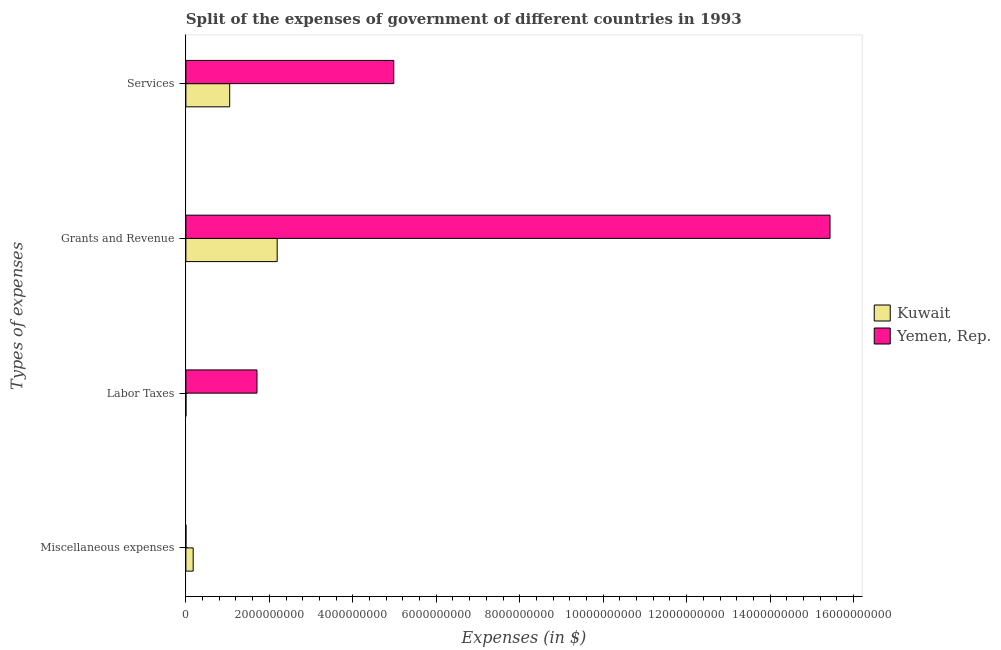Are the number of bars on each tick of the Y-axis equal?
Offer a very short reply. Yes. What is the label of the 2nd group of bars from the top?
Make the answer very short. Grants and Revenue. What is the amount spent on miscellaneous expenses in Yemen, Rep.?
Your answer should be compact. 1.00e+06. Across all countries, what is the maximum amount spent on miscellaneous expenses?
Keep it short and to the point. 1.75e+08. Across all countries, what is the minimum amount spent on labor taxes?
Keep it short and to the point. 2.00e+06. In which country was the amount spent on services maximum?
Make the answer very short. Yemen, Rep. In which country was the amount spent on labor taxes minimum?
Offer a very short reply. Kuwait. What is the total amount spent on grants and revenue in the graph?
Offer a terse response. 1.76e+1. What is the difference between the amount spent on miscellaneous expenses in Yemen, Rep. and that in Kuwait?
Offer a terse response. -1.74e+08. What is the difference between the amount spent on services in Kuwait and the amount spent on grants and revenue in Yemen, Rep.?
Ensure brevity in your answer.  -1.44e+1. What is the average amount spent on grants and revenue per country?
Your answer should be compact. 8.81e+09. What is the difference between the amount spent on labor taxes and amount spent on services in Kuwait?
Provide a succinct answer. -1.05e+09. What is the ratio of the amount spent on miscellaneous expenses in Yemen, Rep. to that in Kuwait?
Your answer should be compact. 0.01. Is the amount spent on services in Kuwait less than that in Yemen, Rep.?
Make the answer very short. Yes. Is the difference between the amount spent on labor taxes in Yemen, Rep. and Kuwait greater than the difference between the amount spent on miscellaneous expenses in Yemen, Rep. and Kuwait?
Your answer should be compact. Yes. What is the difference between the highest and the second highest amount spent on miscellaneous expenses?
Provide a succinct answer. 1.74e+08. What is the difference between the highest and the lowest amount spent on miscellaneous expenses?
Your response must be concise. 1.74e+08. In how many countries, is the amount spent on labor taxes greater than the average amount spent on labor taxes taken over all countries?
Your answer should be compact. 1. Is it the case that in every country, the sum of the amount spent on services and amount spent on labor taxes is greater than the sum of amount spent on grants and revenue and amount spent on miscellaneous expenses?
Give a very brief answer. Yes. What does the 1st bar from the top in Miscellaneous expenses represents?
Offer a very short reply. Yemen, Rep. What does the 1st bar from the bottom in Services represents?
Offer a terse response. Kuwait. Is it the case that in every country, the sum of the amount spent on miscellaneous expenses and amount spent on labor taxes is greater than the amount spent on grants and revenue?
Keep it short and to the point. No. How many bars are there?
Provide a succinct answer. 8. Does the graph contain grids?
Your answer should be very brief. No. Where does the legend appear in the graph?
Ensure brevity in your answer.  Center right. How many legend labels are there?
Your answer should be compact. 2. How are the legend labels stacked?
Your answer should be very brief. Vertical. What is the title of the graph?
Ensure brevity in your answer.  Split of the expenses of government of different countries in 1993. Does "South Africa" appear as one of the legend labels in the graph?
Your response must be concise. No. What is the label or title of the X-axis?
Provide a succinct answer. Expenses (in $). What is the label or title of the Y-axis?
Ensure brevity in your answer.  Types of expenses. What is the Expenses (in $) of Kuwait in Miscellaneous expenses?
Make the answer very short. 1.75e+08. What is the Expenses (in $) of Yemen, Rep. in Labor Taxes?
Provide a succinct answer. 1.70e+09. What is the Expenses (in $) of Kuwait in Grants and Revenue?
Provide a succinct answer. 2.19e+09. What is the Expenses (in $) of Yemen, Rep. in Grants and Revenue?
Make the answer very short. 1.54e+1. What is the Expenses (in $) of Kuwait in Services?
Offer a terse response. 1.05e+09. What is the Expenses (in $) of Yemen, Rep. in Services?
Ensure brevity in your answer.  4.98e+09. Across all Types of expenses, what is the maximum Expenses (in $) in Kuwait?
Offer a terse response. 2.19e+09. Across all Types of expenses, what is the maximum Expenses (in $) of Yemen, Rep.?
Make the answer very short. 1.54e+1. Across all Types of expenses, what is the minimum Expenses (in $) of Kuwait?
Make the answer very short. 2.00e+06. Across all Types of expenses, what is the minimum Expenses (in $) of Yemen, Rep.?
Your response must be concise. 1.00e+06. What is the total Expenses (in $) in Kuwait in the graph?
Offer a very short reply. 3.42e+09. What is the total Expenses (in $) in Yemen, Rep. in the graph?
Offer a very short reply. 2.21e+1. What is the difference between the Expenses (in $) of Kuwait in Miscellaneous expenses and that in Labor Taxes?
Your answer should be compact. 1.73e+08. What is the difference between the Expenses (in $) in Yemen, Rep. in Miscellaneous expenses and that in Labor Taxes?
Provide a short and direct response. -1.70e+09. What is the difference between the Expenses (in $) in Kuwait in Miscellaneous expenses and that in Grants and Revenue?
Your answer should be very brief. -2.01e+09. What is the difference between the Expenses (in $) in Yemen, Rep. in Miscellaneous expenses and that in Grants and Revenue?
Your answer should be compact. -1.54e+1. What is the difference between the Expenses (in $) in Kuwait in Miscellaneous expenses and that in Services?
Your response must be concise. -8.75e+08. What is the difference between the Expenses (in $) in Yemen, Rep. in Miscellaneous expenses and that in Services?
Offer a terse response. -4.98e+09. What is the difference between the Expenses (in $) in Kuwait in Labor Taxes and that in Grants and Revenue?
Offer a terse response. -2.19e+09. What is the difference between the Expenses (in $) of Yemen, Rep. in Labor Taxes and that in Grants and Revenue?
Keep it short and to the point. -1.37e+1. What is the difference between the Expenses (in $) of Kuwait in Labor Taxes and that in Services?
Your answer should be very brief. -1.05e+09. What is the difference between the Expenses (in $) of Yemen, Rep. in Labor Taxes and that in Services?
Offer a terse response. -3.28e+09. What is the difference between the Expenses (in $) in Kuwait in Grants and Revenue and that in Services?
Give a very brief answer. 1.14e+09. What is the difference between the Expenses (in $) in Yemen, Rep. in Grants and Revenue and that in Services?
Ensure brevity in your answer.  1.05e+1. What is the difference between the Expenses (in $) of Kuwait in Miscellaneous expenses and the Expenses (in $) of Yemen, Rep. in Labor Taxes?
Your response must be concise. -1.53e+09. What is the difference between the Expenses (in $) in Kuwait in Miscellaneous expenses and the Expenses (in $) in Yemen, Rep. in Grants and Revenue?
Offer a terse response. -1.53e+1. What is the difference between the Expenses (in $) of Kuwait in Miscellaneous expenses and the Expenses (in $) of Yemen, Rep. in Services?
Make the answer very short. -4.81e+09. What is the difference between the Expenses (in $) in Kuwait in Labor Taxes and the Expenses (in $) in Yemen, Rep. in Grants and Revenue?
Make the answer very short. -1.54e+1. What is the difference between the Expenses (in $) in Kuwait in Labor Taxes and the Expenses (in $) in Yemen, Rep. in Services?
Offer a terse response. -4.98e+09. What is the difference between the Expenses (in $) in Kuwait in Grants and Revenue and the Expenses (in $) in Yemen, Rep. in Services?
Offer a very short reply. -2.79e+09. What is the average Expenses (in $) of Kuwait per Types of expenses?
Make the answer very short. 8.54e+08. What is the average Expenses (in $) in Yemen, Rep. per Types of expenses?
Make the answer very short. 5.53e+09. What is the difference between the Expenses (in $) in Kuwait and Expenses (in $) in Yemen, Rep. in Miscellaneous expenses?
Keep it short and to the point. 1.74e+08. What is the difference between the Expenses (in $) of Kuwait and Expenses (in $) of Yemen, Rep. in Labor Taxes?
Your answer should be very brief. -1.70e+09. What is the difference between the Expenses (in $) in Kuwait and Expenses (in $) in Yemen, Rep. in Grants and Revenue?
Provide a short and direct response. -1.32e+1. What is the difference between the Expenses (in $) in Kuwait and Expenses (in $) in Yemen, Rep. in Services?
Offer a very short reply. -3.93e+09. What is the ratio of the Expenses (in $) of Kuwait in Miscellaneous expenses to that in Labor Taxes?
Provide a short and direct response. 87.5. What is the ratio of the Expenses (in $) in Yemen, Rep. in Miscellaneous expenses to that in Labor Taxes?
Your answer should be very brief. 0. What is the ratio of the Expenses (in $) of Kuwait in Miscellaneous expenses to that in Grants and Revenue?
Keep it short and to the point. 0.08. What is the ratio of the Expenses (in $) of Yemen, Rep. in Miscellaneous expenses to that in Grants and Revenue?
Provide a short and direct response. 0. What is the ratio of the Expenses (in $) of Yemen, Rep. in Miscellaneous expenses to that in Services?
Your response must be concise. 0. What is the ratio of the Expenses (in $) in Kuwait in Labor Taxes to that in Grants and Revenue?
Your answer should be compact. 0. What is the ratio of the Expenses (in $) in Yemen, Rep. in Labor Taxes to that in Grants and Revenue?
Offer a very short reply. 0.11. What is the ratio of the Expenses (in $) of Kuwait in Labor Taxes to that in Services?
Provide a short and direct response. 0. What is the ratio of the Expenses (in $) of Yemen, Rep. in Labor Taxes to that in Services?
Ensure brevity in your answer.  0.34. What is the ratio of the Expenses (in $) of Kuwait in Grants and Revenue to that in Services?
Your response must be concise. 2.08. What is the ratio of the Expenses (in $) of Yemen, Rep. in Grants and Revenue to that in Services?
Your response must be concise. 3.1. What is the difference between the highest and the second highest Expenses (in $) in Kuwait?
Provide a short and direct response. 1.14e+09. What is the difference between the highest and the second highest Expenses (in $) in Yemen, Rep.?
Make the answer very short. 1.05e+1. What is the difference between the highest and the lowest Expenses (in $) of Kuwait?
Provide a short and direct response. 2.19e+09. What is the difference between the highest and the lowest Expenses (in $) in Yemen, Rep.?
Provide a succinct answer. 1.54e+1. 